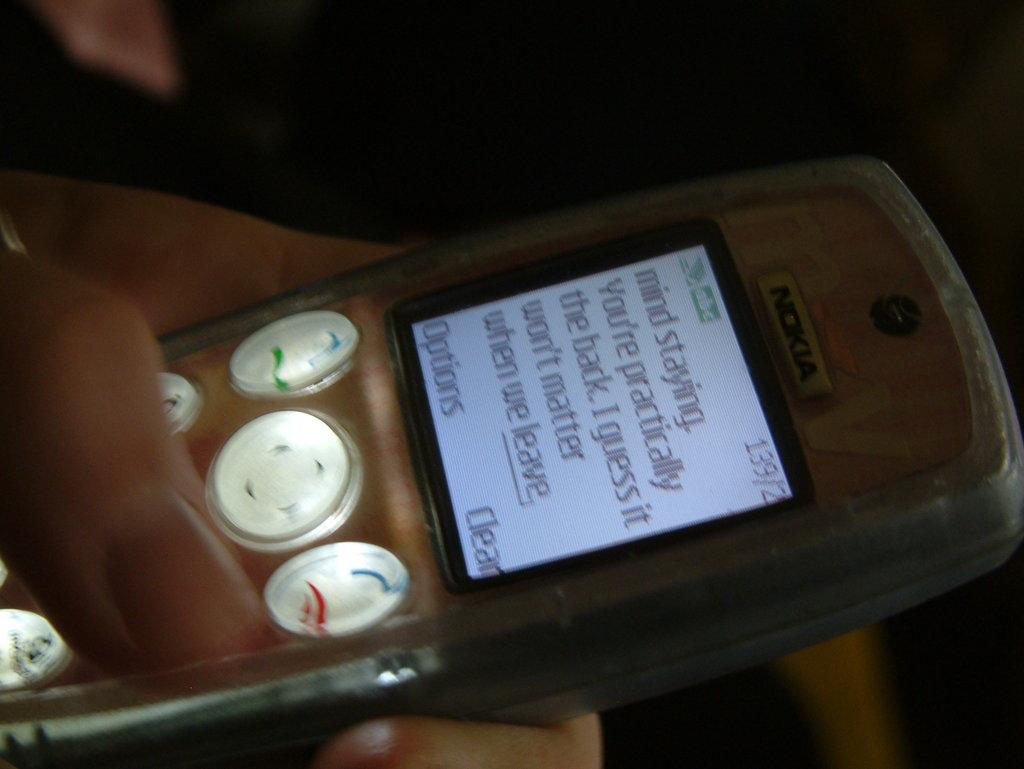<image>
Provide a brief description of the given image. An old Nokia phone is seen close up with a partial message visible on its home screen. 